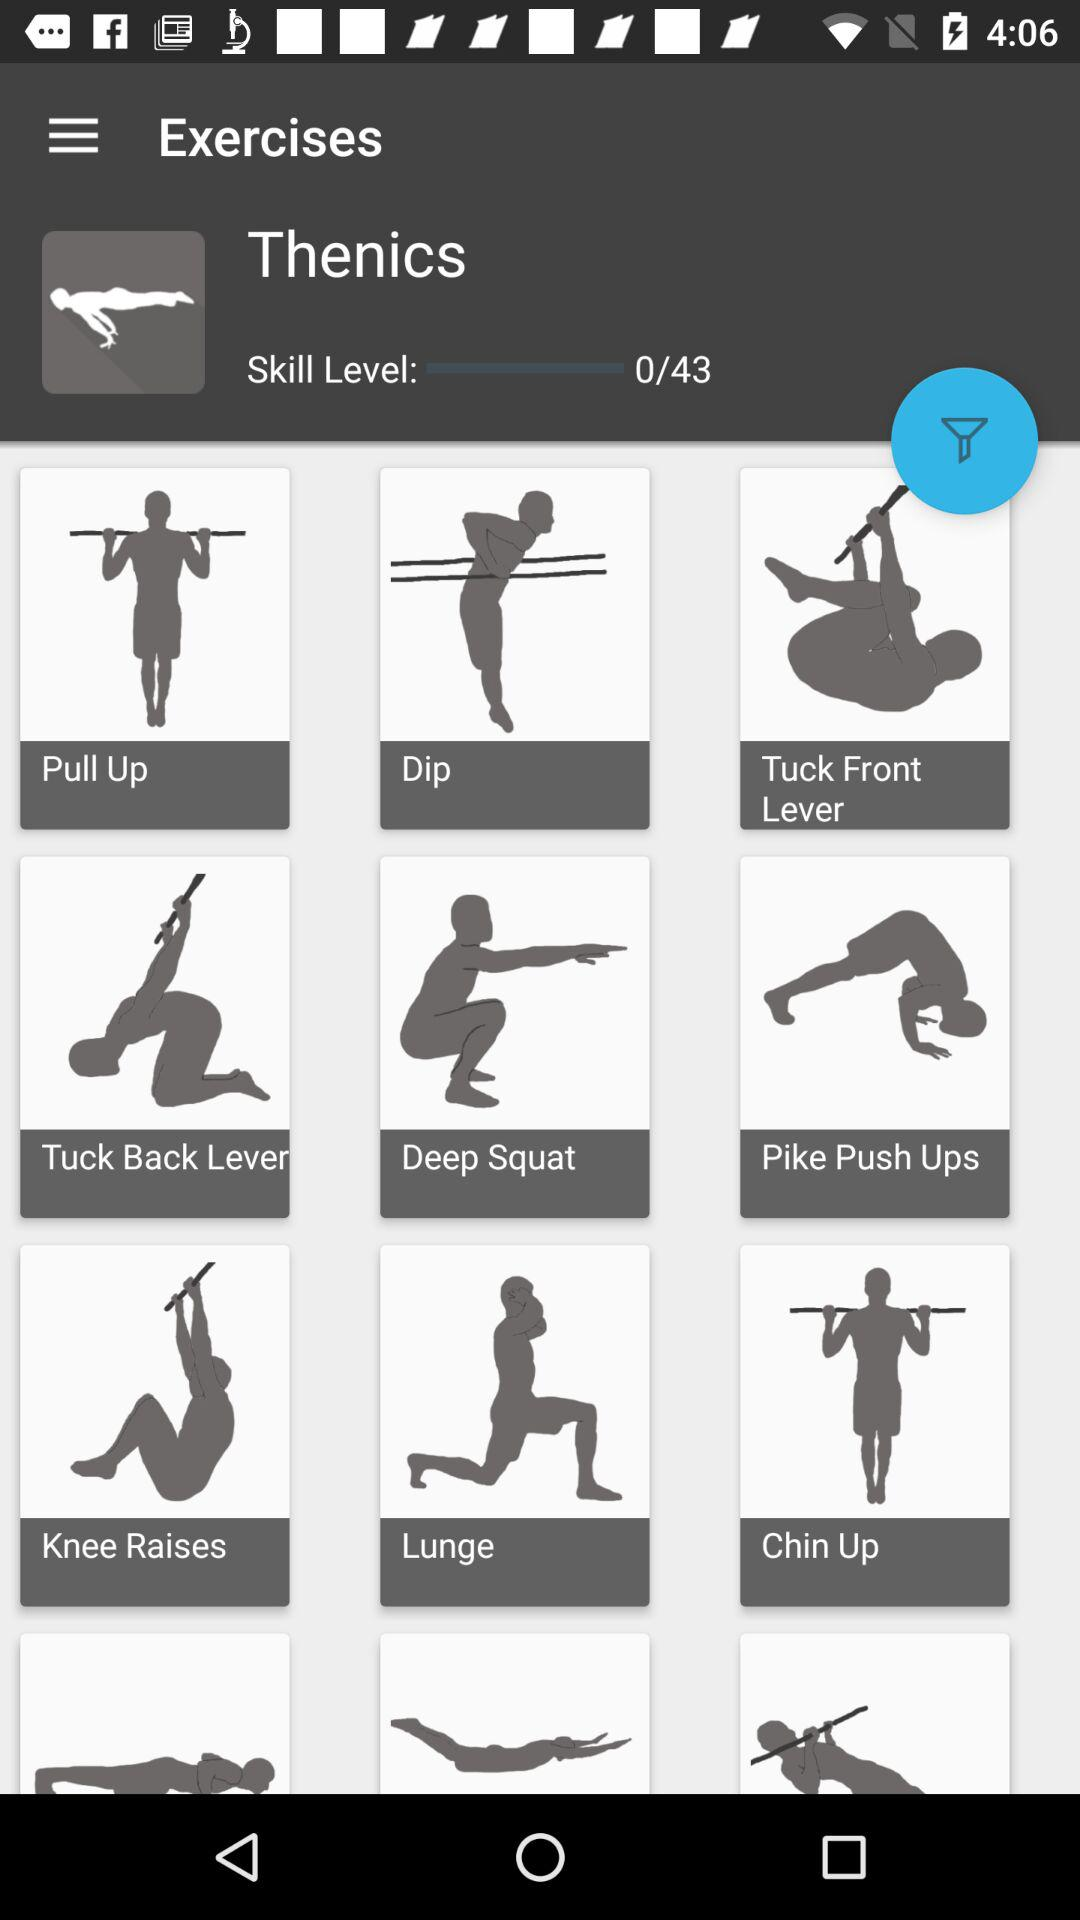What is the skill level of Thenics? The skill level of Thenics is 0. 